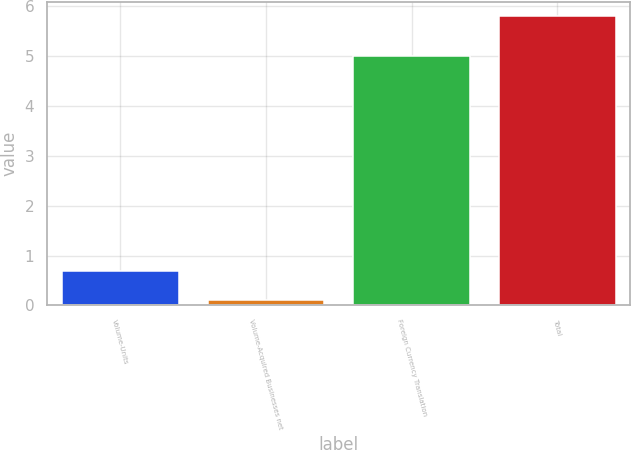<chart> <loc_0><loc_0><loc_500><loc_500><bar_chart><fcel>Volume-Units<fcel>Volume-Acquired Businesses net<fcel>Foreign Currency Translation<fcel>Total<nl><fcel>0.7<fcel>0.1<fcel>5<fcel>5.8<nl></chart> 